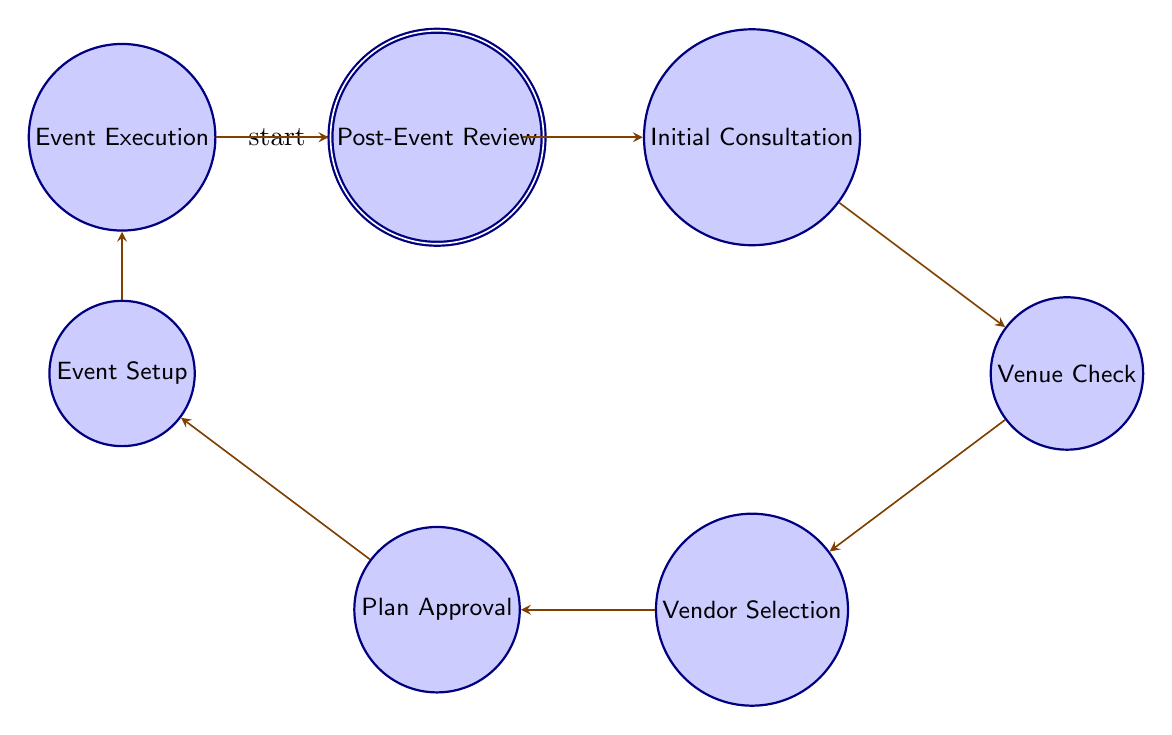What is the first state in the diagram? The first state in the diagram is denoted as the initial state, which is "Event_Request_Received." This can be determined by observing the node labeled with the "initial" mark.
Answer: Event_Request_Received How many states are in the diagram? The diagram lists a total of 8 different states, each represented as a node. By counting the nodes shown, we find that there are eight states present.
Answer: 8 What state follows "Vendor_Selection"? To determine the state that follows "Vendor_Selection," we look at the directed edges from the "Vendor_Selection" node. The edge leads to the next state, which is "Plan_Approval."
Answer: Plan_Approval What is the ending state of the event coordination process? The ending state is identifiable as it receives the "accepting" label, which marks the completion of the flow. The final state is "Post_Event_Review."
Answer: Post_Event_Review Which state requires a meeting with the client? The state where a consultation meeting is held with the client, aimed at understanding their requirements, is called "Initial_Consultation." This is directly indicated in the node description.
Answer: Initial_Consultation What is the transition from "Event_Setup"? To find the transition from "Event_Setup," we check where the arrow leads from that node. It flows into the state labeled "Event_Execution." Thus, the transition indicates the next state.
Answer: Event_Execution How many transitions are in the diagram? By examining the edges connecting the states, we can count a total of 7 transitions, as each arrow corresponds to a transition between two nodes.
Answer: 7 What state comes after "Plan_Approval"? Observing the transition starting from "Plan_Approval," we notice that it leads directly to "Event_Setup." Hence, this is the next state in the sequence.
Answer: Event_Setup 